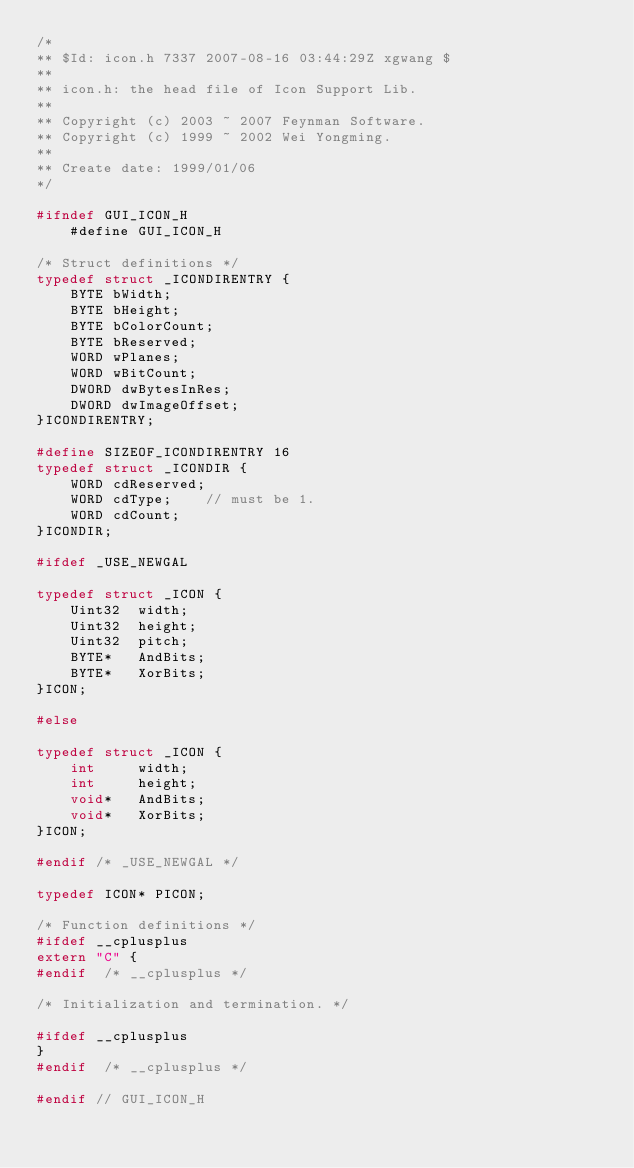Convert code to text. <code><loc_0><loc_0><loc_500><loc_500><_C_>/*
** $Id: icon.h 7337 2007-08-16 03:44:29Z xgwang $
**
** icon.h: the head file of Icon Support Lib.
**
** Copyright (c) 2003 ~ 2007 Feynman Software.
** Copyright (c) 1999 ~ 2002 Wei Yongming.
**
** Create date: 1999/01/06
*/

#ifndef GUI_ICON_H
    #define GUI_ICON_H

/* Struct definitions */
typedef struct _ICONDIRENTRY {
    BYTE bWidth;
    BYTE bHeight;
    BYTE bColorCount;
    BYTE bReserved;
    WORD wPlanes;
    WORD wBitCount;
    DWORD dwBytesInRes;
    DWORD dwImageOffset;
}ICONDIRENTRY;

#define SIZEOF_ICONDIRENTRY 16
typedef struct _ICONDIR {
    WORD cdReserved;
    WORD cdType;    // must be 1.
    WORD cdCount;
}ICONDIR;

#ifdef _USE_NEWGAL

typedef struct _ICON {
    Uint32  width;
    Uint32  height;
    Uint32  pitch;
    BYTE*   AndBits;
    BYTE*   XorBits;
}ICON;

#else

typedef struct _ICON {
    int     width;
    int     height;
    void*   AndBits;
    void*   XorBits;
}ICON;

#endif /* _USE_NEWGAL */

typedef ICON* PICON;

/* Function definitions */
#ifdef __cplusplus
extern "C" {
#endif  /* __cplusplus */

/* Initialization and termination. */

#ifdef __cplusplus
}
#endif  /* __cplusplus */

#endif // GUI_ICON_H

</code> 